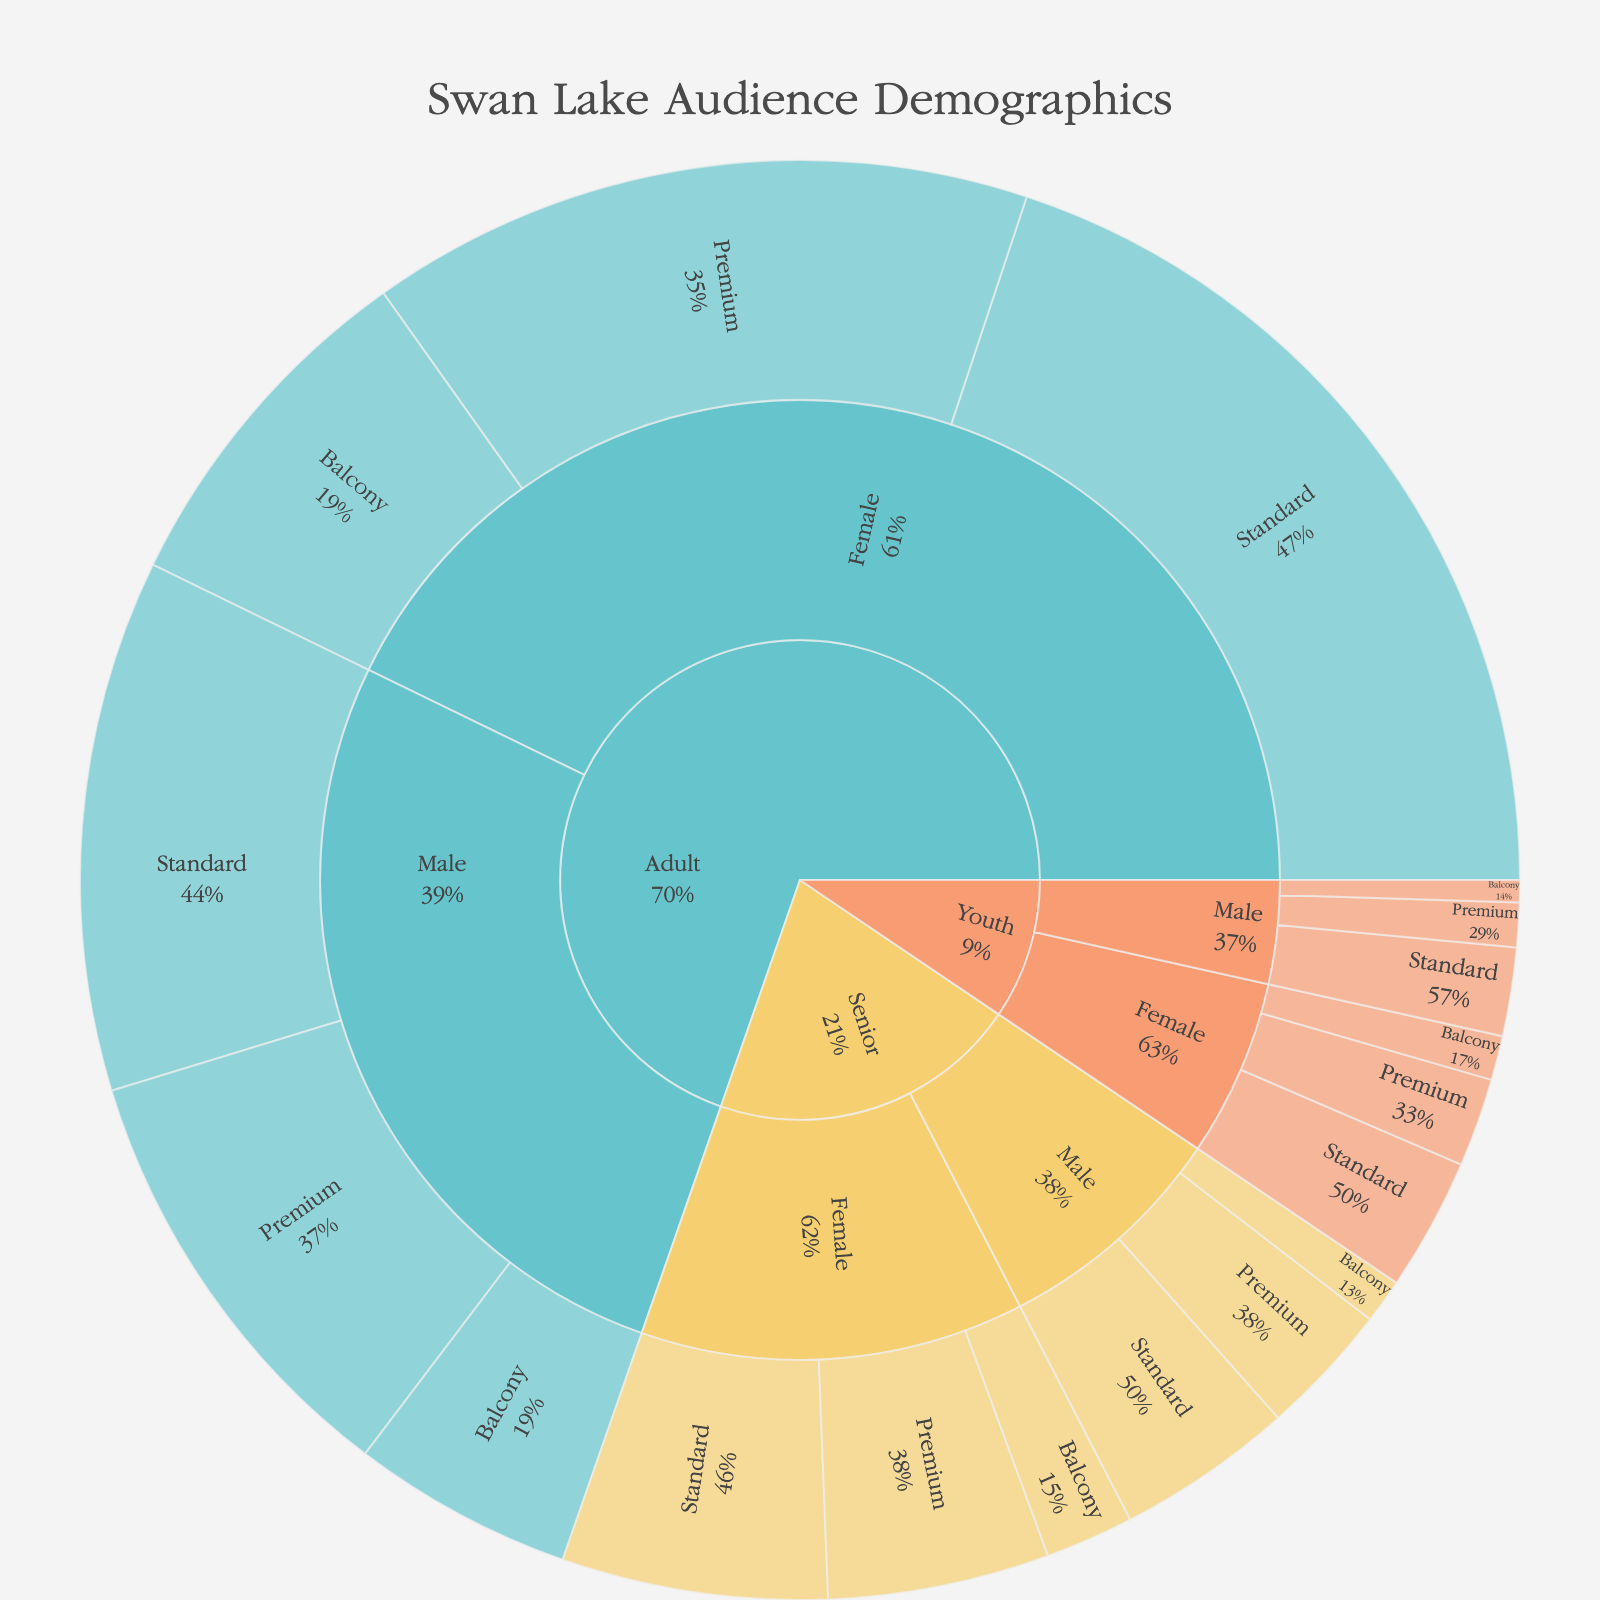What's the title of this Sunburst plot? The plot's title is centered at the top and reads "Swan Lake Audience Demographics".
Answer: Swan Lake Audience Demographics What gender of Adults bought more Premium tickets? First, look at the 'Adult' section of the Sunburst plot. Then, compare the percentages of Premium tickets for 'Female' and 'Male' sections. Female Adults bought 15% Premium tickets whereas Male Adults bought 10%.
Answer: Female How many percentage points do Adult Female guests account for in Balcony tickets? From the 'Adult' > 'Female' > 'Balcony' part of the Sunburst plot, we see that Adult Female guests account for 8% of Balcony tickets.
Answer: 8 Compare the percentages of Senior Male and Youth Female guests who purchased Standard tickets. Locate the Standard ticket type under 'Senior' > 'Male' and 'Youth' > 'Female'. Senior Males make up 4%, while Youth Females make up 3%. The percentage for Senior Males is greater.
Answer: Senior Males have a higher percentage What is the total percentage of all Youth ticket purchases? Sum all the percentages for 'Youth'. Add percentages for Female (2% + 3% + 1%) and Male (1% + 2% + 0.5%). The total percentage is 9.5%.
Answer: 9.5 Which age group has the lowest percentage for Balcony ticket purchases? Compare the percentages in the Balcony ticket sections for Adults, Seniors, and Youths. Youth Males bought 0.5% (lowest), so 'Youth' is the age group with the lowest percentage overall.
Answer: Youth What percentage of the total tickets were purchased by Seniors? Sum the percentages of all ticket types under the 'Senior' section. 5% + 6% + 2% (Females) and 3% + 4% + 1% (Males). The total is 21%.
Answer: 21 How does the proportion of Female Premium tickets compare between Adults and Seniors? Compare the sections for Adult > Female > Premium (15%) and Senior > Female > Premium (5%). Adults have a higher proportion.
Answer: Adults have a higher proportion What is the combined percentage of Male Premium ticket holders across all age groups? Sum the percentages of Premium ticket sections under 'Male' for all ages: 10% (Adult), 3% (Senior), 1% (Youth). The total is 14%.
Answer: 14 What is the percentage difference between Adult Male Standard tickets and Youth Male Standard tickets? Look at the Standard ticket sections for Adult > Male (12%) and Youth > Male (2%). The difference is 12% - 2% = 10%.
Answer: 10% 